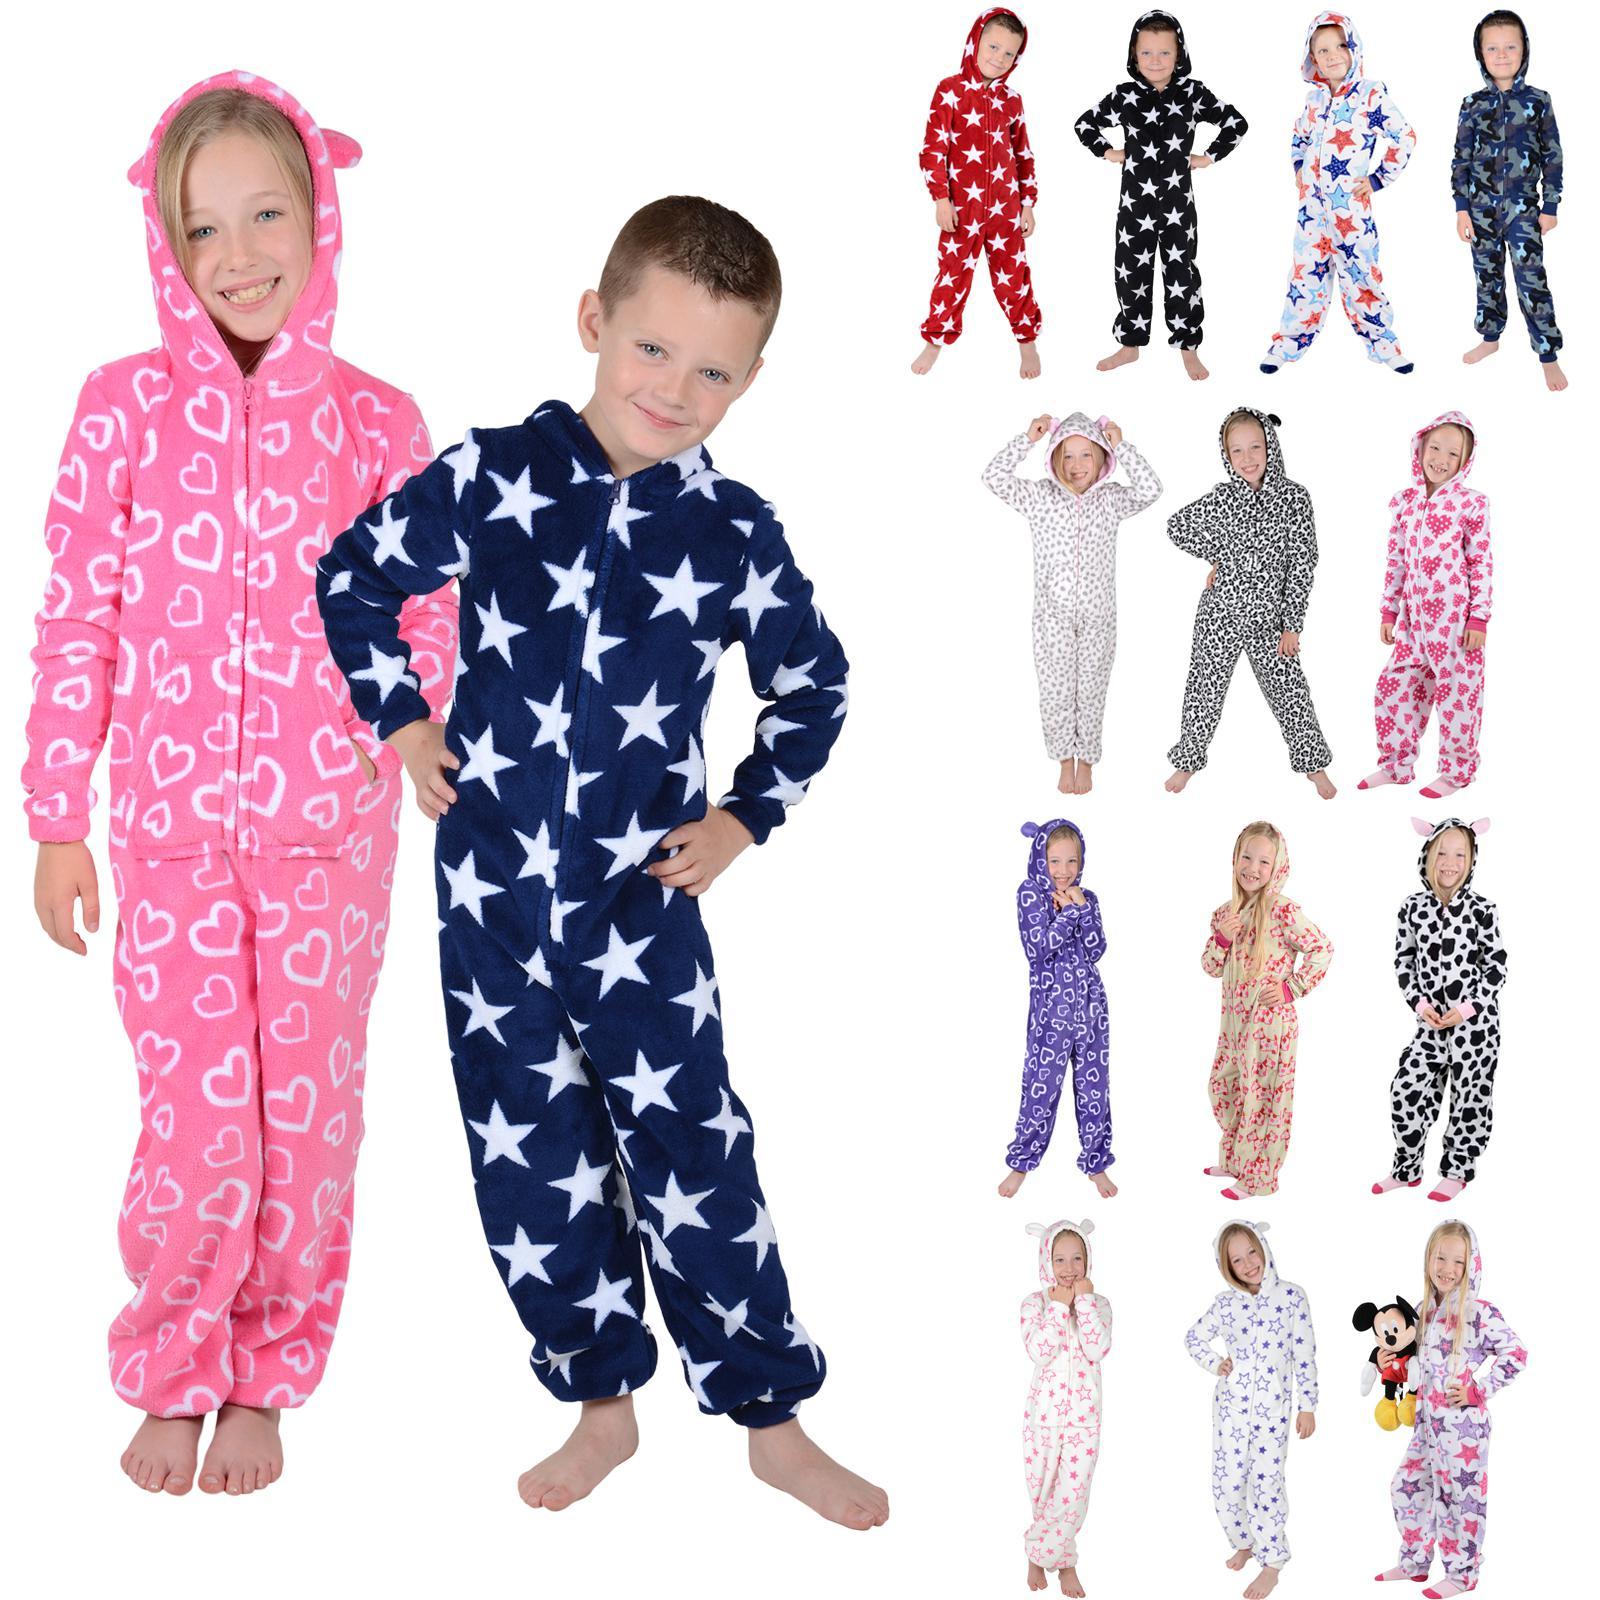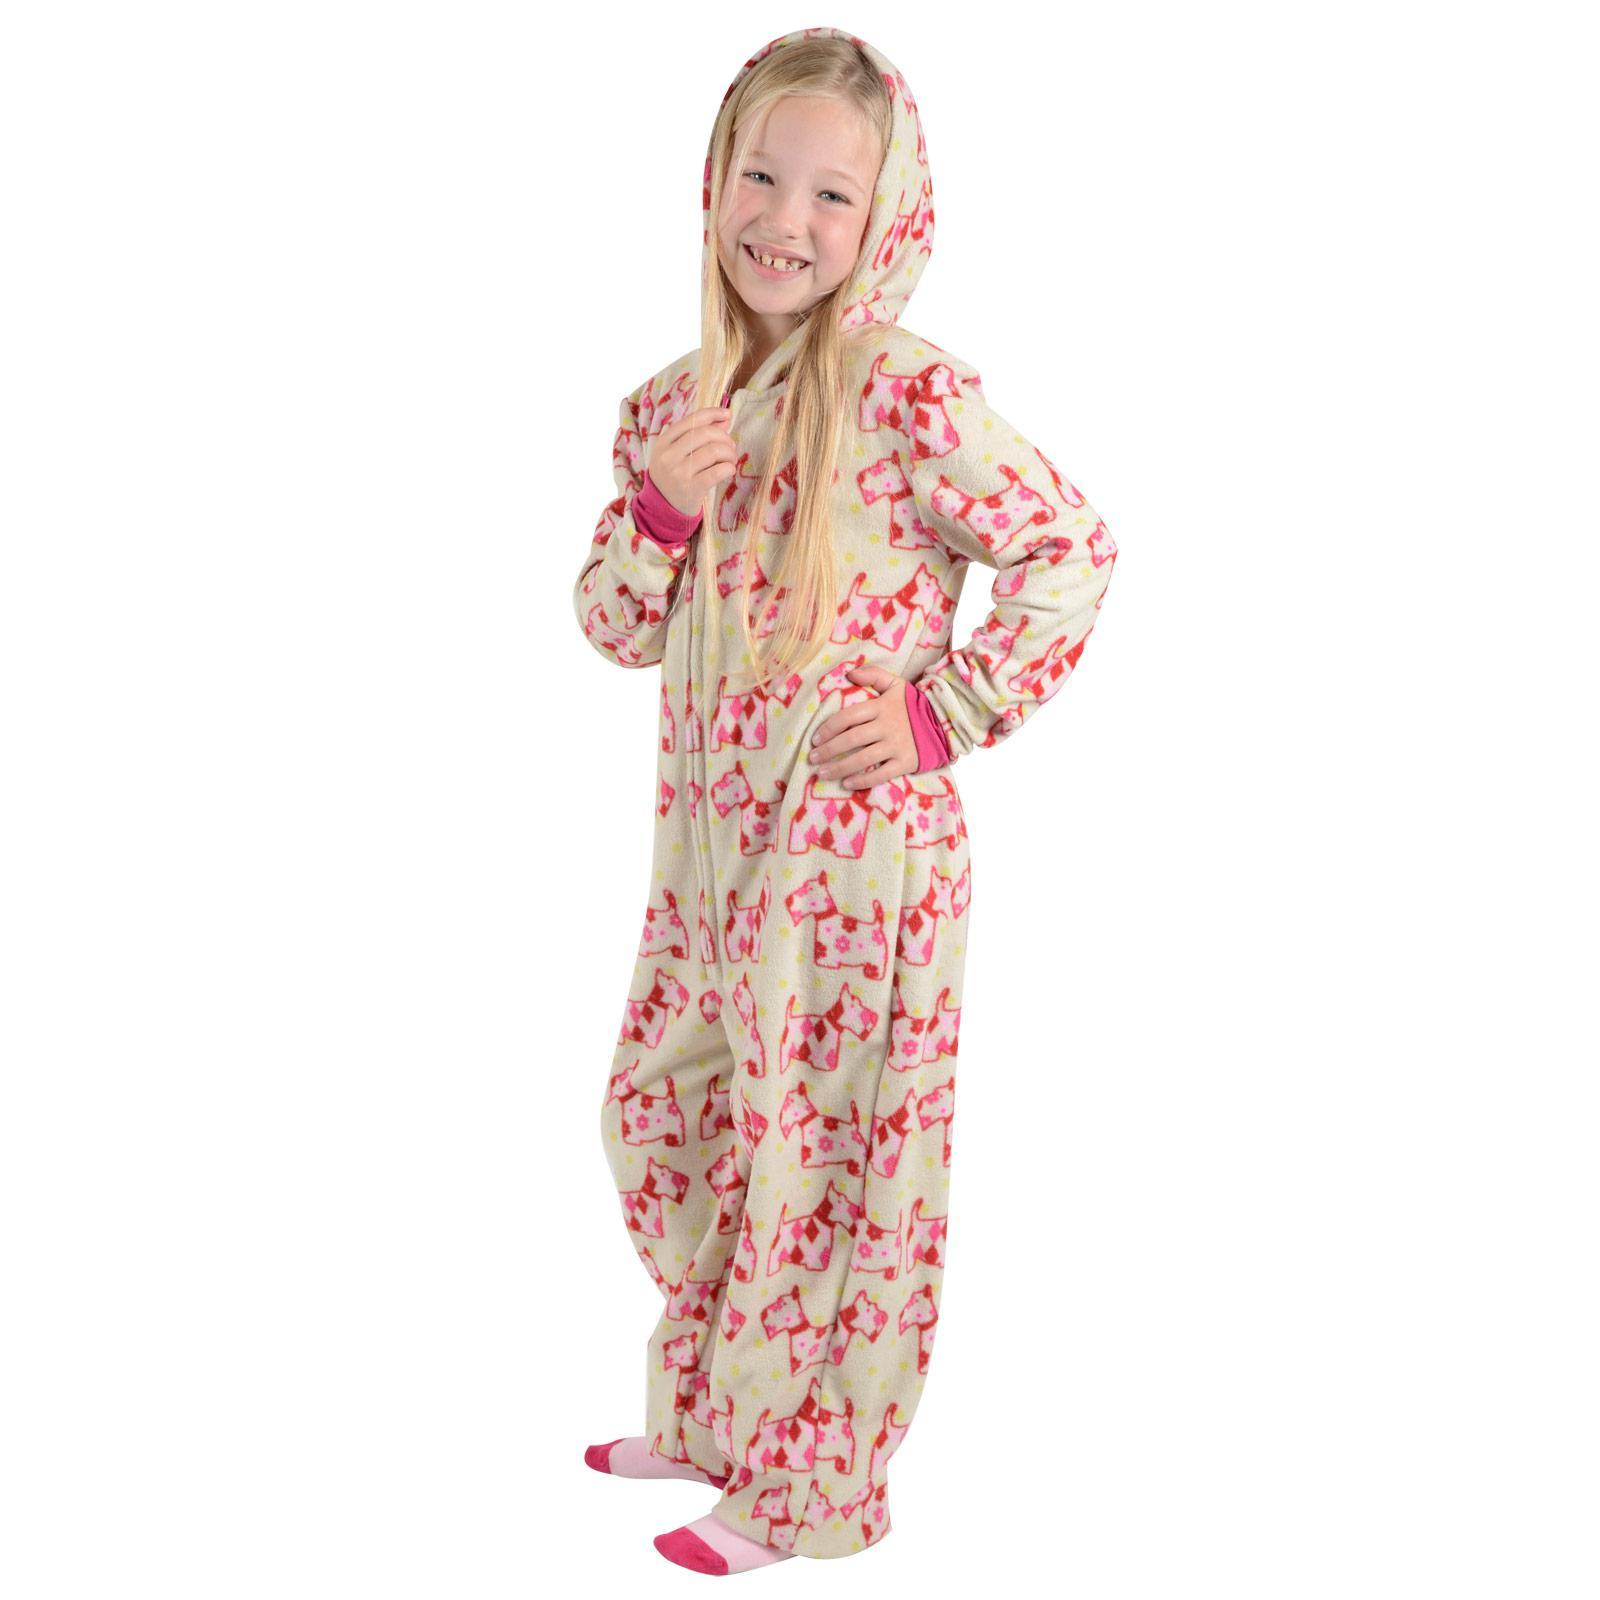The first image is the image on the left, the second image is the image on the right. Analyze the images presented: Is the assertion "At least 1 child is wearing blue patterned pajamas." valid? Answer yes or no. Yes. The first image is the image on the left, the second image is the image on the right. Analyze the images presented: Is the assertion "There is more than one child in total." valid? Answer yes or no. Yes. 